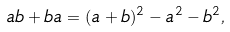<formula> <loc_0><loc_0><loc_500><loc_500>a b + b a = ( a + b ) ^ { 2 } - a ^ { 2 } - b ^ { 2 } ,</formula> 